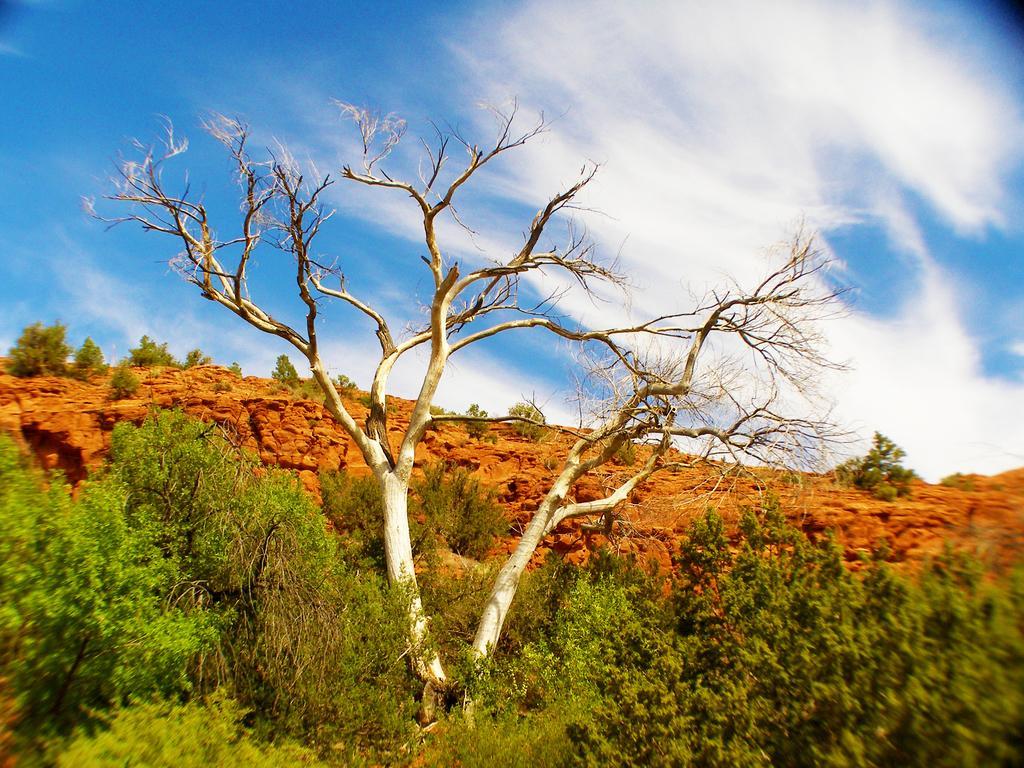Please provide a concise description of this image. In this picture we can see trees and in the background we can see sky with clouds. 